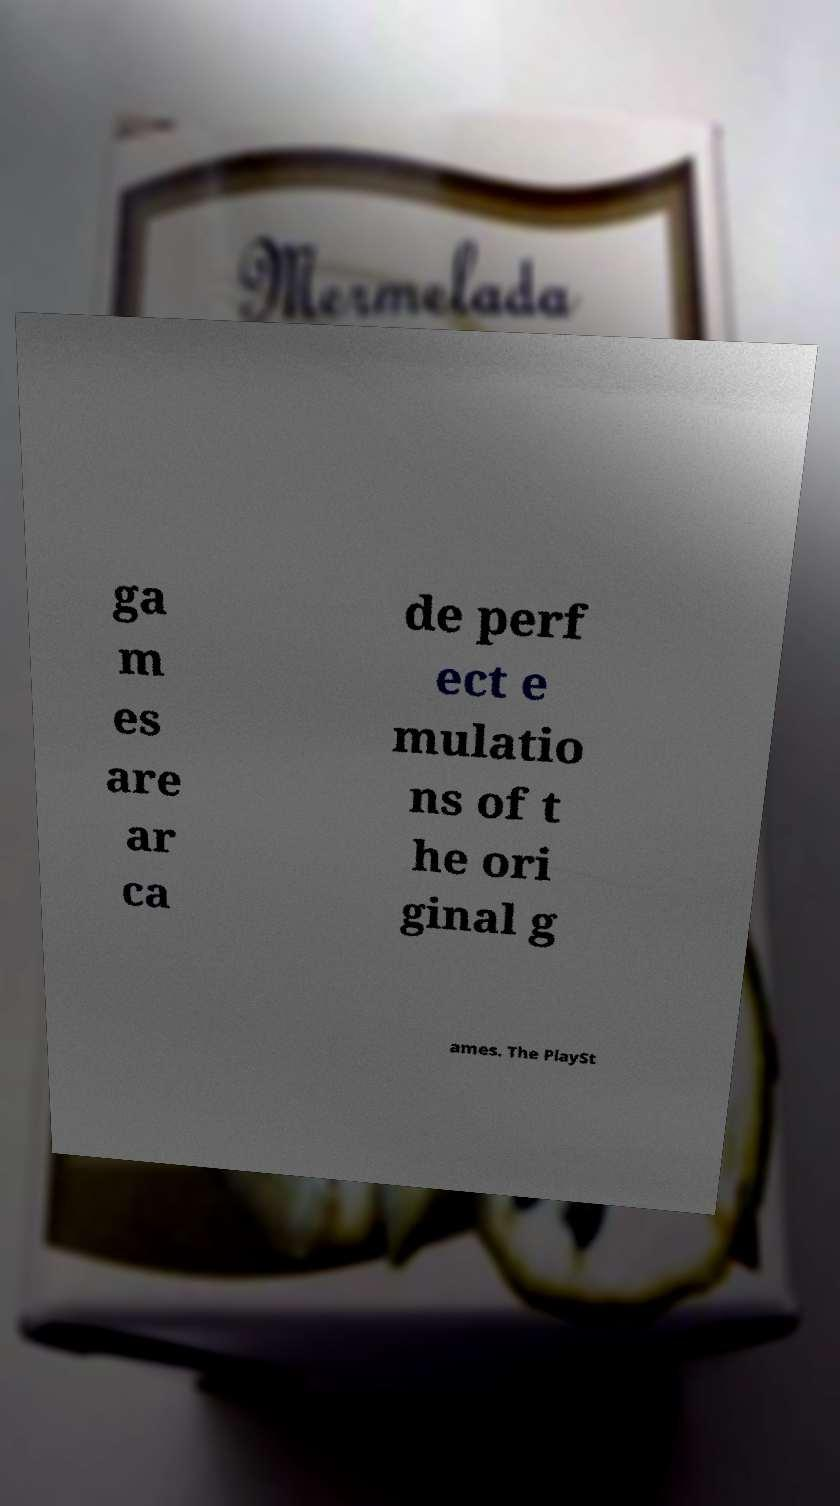Please identify and transcribe the text found in this image. ga m es are ar ca de perf ect e mulatio ns of t he ori ginal g ames. The PlaySt 